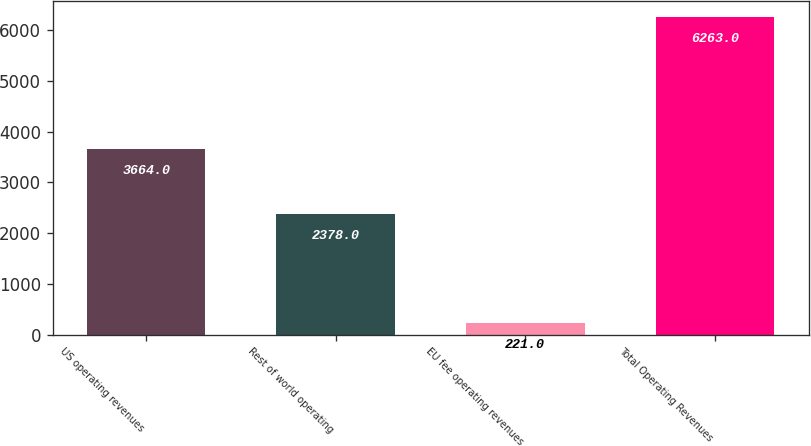Convert chart to OTSL. <chart><loc_0><loc_0><loc_500><loc_500><bar_chart><fcel>US operating revenues<fcel>Rest of world operating<fcel>EU fee operating revenues<fcel>Total Operating Revenues<nl><fcel>3664<fcel>2378<fcel>221<fcel>6263<nl></chart> 